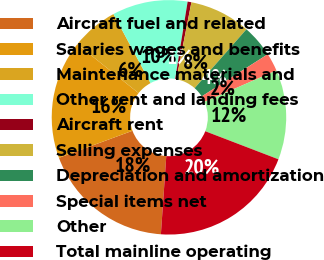Convert chart. <chart><loc_0><loc_0><loc_500><loc_500><pie_chart><fcel>Aircraft fuel and related<fcel>Salaries wages and benefits<fcel>Maintenance materials and<fcel>Other rent and landing fees<fcel>Aircraft rent<fcel>Selling expenses<fcel>Depreciation and amortization<fcel>Special items net<fcel>Other<fcel>Total mainline operating<nl><fcel>18.29%<fcel>16.32%<fcel>6.45%<fcel>10.39%<fcel>0.52%<fcel>8.42%<fcel>4.47%<fcel>2.5%<fcel>12.37%<fcel>20.27%<nl></chart> 